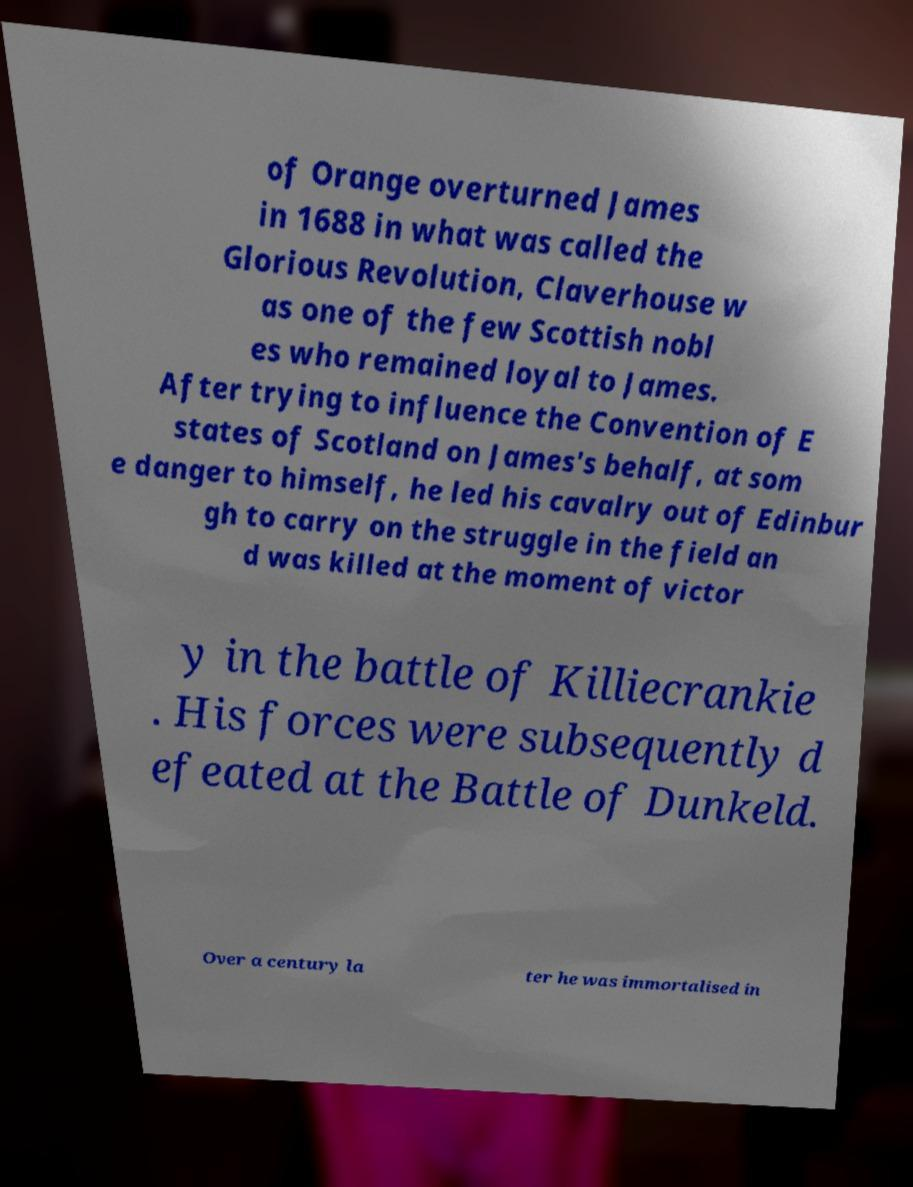Please identify and transcribe the text found in this image. of Orange overturned James in 1688 in what was called the Glorious Revolution, Claverhouse w as one of the few Scottish nobl es who remained loyal to James. After trying to influence the Convention of E states of Scotland on James's behalf, at som e danger to himself, he led his cavalry out of Edinbur gh to carry on the struggle in the field an d was killed at the moment of victor y in the battle of Killiecrankie . His forces were subsequently d efeated at the Battle of Dunkeld. Over a century la ter he was immortalised in 